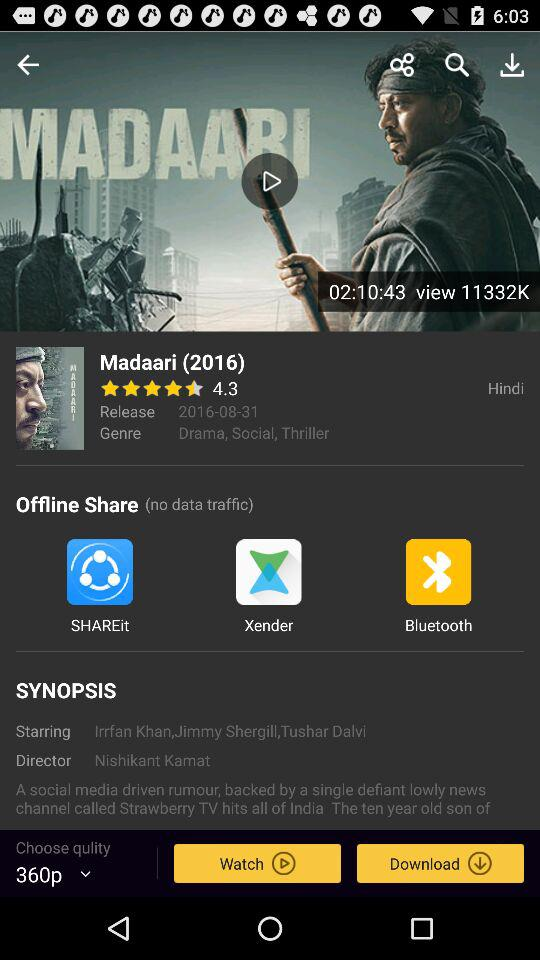What is the duration and the total number of views of the movie? The movie's duration and total number of views are 2 hours 10 minutes 43 seconds and 11332000 respectively. 